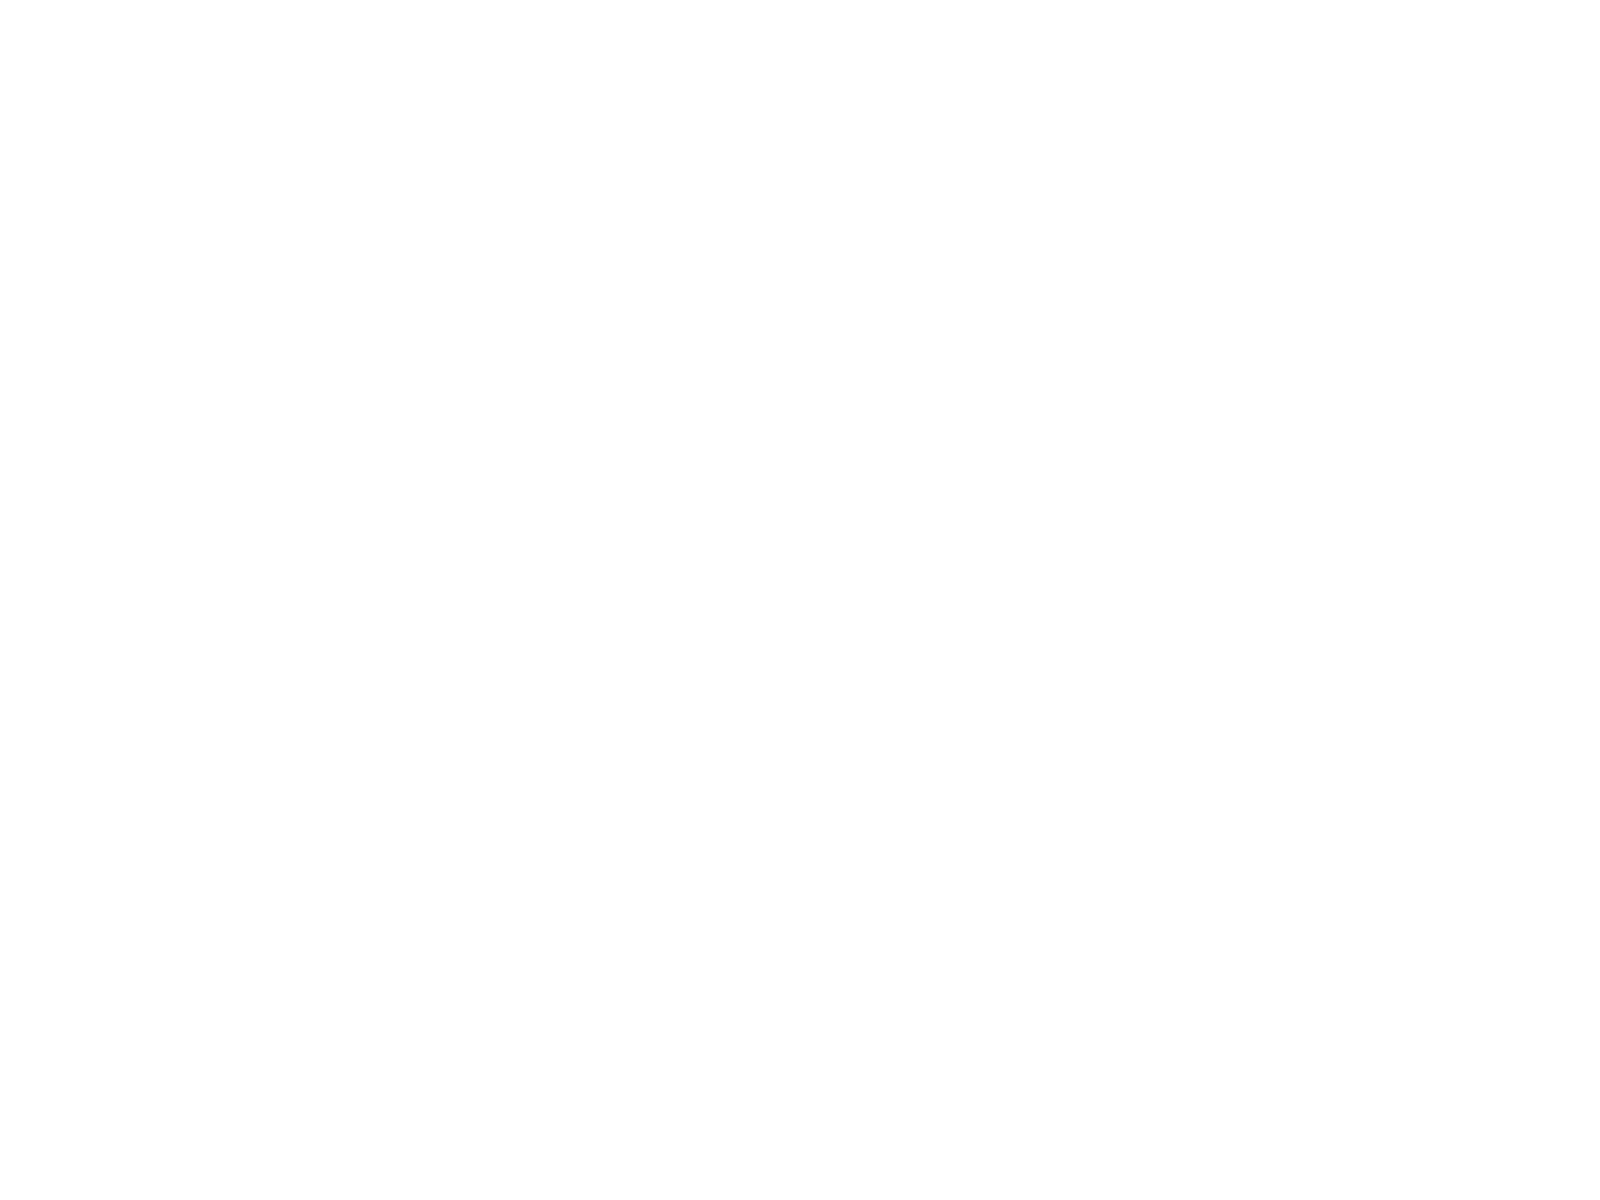<chart> <loc_0><loc_0><loc_500><loc_500><pie_chart><fcel>( of Pre-tax income)<fcel>Federal<fcel>State income tax<fcel>Cost of removal<fcel>Effective tax rate<nl><fcel>62.24%<fcel>18.76%<fcel>0.12%<fcel>6.34%<fcel>12.55%<nl></chart> 